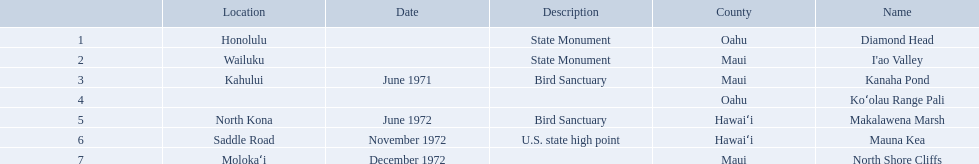What are all the landmark names? Diamond Head, I'ao Valley, Kanaha Pond, Koʻolau Range Pali, Makalawena Marsh, Mauna Kea, North Shore Cliffs. Which county is each landlord in? Oahu, Maui, Maui, Oahu, Hawaiʻi, Hawaiʻi, Maui. Along with mauna kea, which landmark is in hawai'i county? Makalawena Marsh. What are the names of the different hawaiian national landmarks Diamond Head, I'ao Valley, Kanaha Pond, Koʻolau Range Pali, Makalawena Marsh, Mauna Kea, North Shore Cliffs. Which landmark does not have a location listed? Koʻolau Range Pali. 